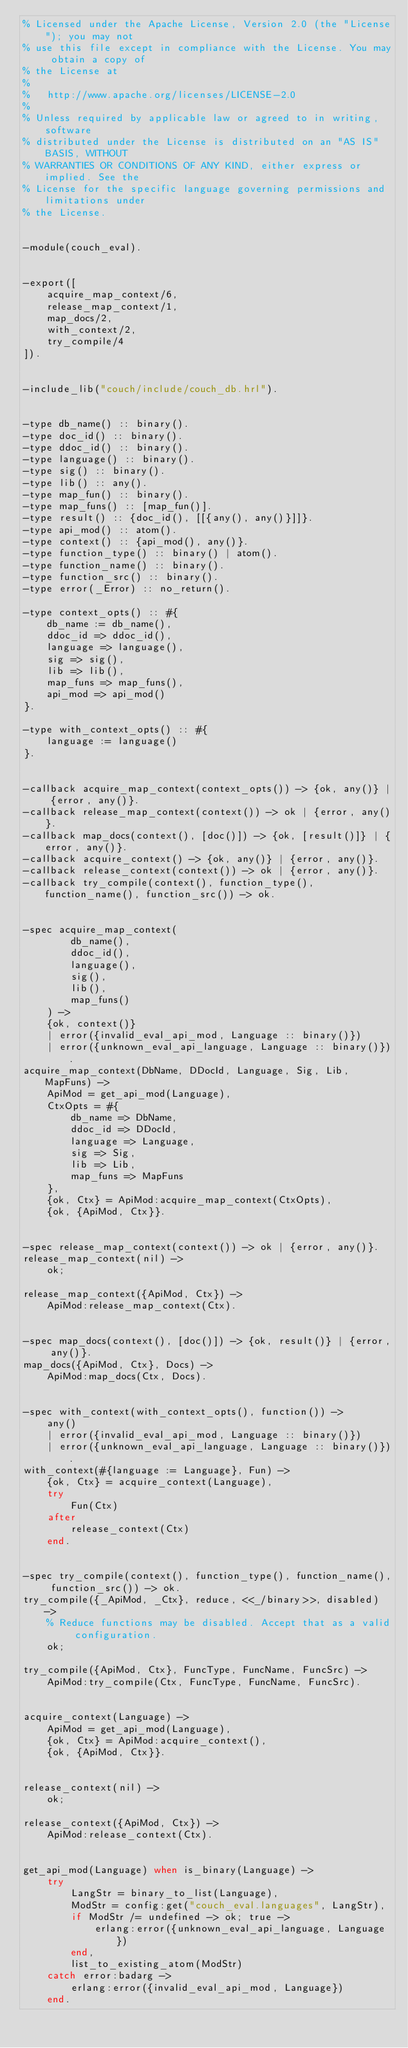<code> <loc_0><loc_0><loc_500><loc_500><_Erlang_>% Licensed under the Apache License, Version 2.0 (the "License"); you may not
% use this file except in compliance with the License. You may obtain a copy of
% the License at
%
%   http://www.apache.org/licenses/LICENSE-2.0
%
% Unless required by applicable law or agreed to in writing, software
% distributed under the License is distributed on an "AS IS" BASIS, WITHOUT
% WARRANTIES OR CONDITIONS OF ANY KIND, either express or implied. See the
% License for the specific language governing permissions and limitations under
% the License.


-module(couch_eval).


-export([
    acquire_map_context/6,
    release_map_context/1,
    map_docs/2,
    with_context/2,
    try_compile/4
]).


-include_lib("couch/include/couch_db.hrl").


-type db_name() :: binary().
-type doc_id() :: binary().
-type ddoc_id() :: binary().
-type language() :: binary().
-type sig() :: binary().
-type lib() :: any().
-type map_fun() :: binary().
-type map_funs() :: [map_fun()].
-type result() :: {doc_id(), [[{any(), any()}]]}.
-type api_mod() :: atom().
-type context() :: {api_mod(), any()}.
-type function_type() :: binary() | atom().
-type function_name() :: binary().
-type function_src() :: binary().
-type error(_Error) :: no_return().

-type context_opts() :: #{
    db_name := db_name(),
    ddoc_id => ddoc_id(),
    language => language(),
    sig => sig(),
    lib => lib(),
    map_funs => map_funs(),
    api_mod => api_mod()
}.

-type with_context_opts() :: #{
    language := language()
}.


-callback acquire_map_context(context_opts()) -> {ok, any()} | {error, any()}.
-callback release_map_context(context()) -> ok | {error, any()}.
-callback map_docs(context(), [doc()]) -> {ok, [result()]} | {error, any()}.
-callback acquire_context() -> {ok, any()} | {error, any()}.
-callback release_context(context()) -> ok | {error, any()}.
-callback try_compile(context(), function_type(), function_name(), function_src()) -> ok.


-spec acquire_map_context(
        db_name(),
        ddoc_id(),
        language(),
        sig(),
        lib(),
        map_funs()
    ) ->
    {ok, context()}
    | error({invalid_eval_api_mod, Language :: binary()})
    | error({unknown_eval_api_language, Language :: binary()}).
acquire_map_context(DbName, DDocId, Language, Sig, Lib, MapFuns) ->
    ApiMod = get_api_mod(Language),
    CtxOpts = #{
        db_name => DbName,
        ddoc_id => DDocId,
        language => Language,
        sig => Sig,
        lib => Lib,
        map_funs => MapFuns
    },
    {ok, Ctx} = ApiMod:acquire_map_context(CtxOpts),
    {ok, {ApiMod, Ctx}}.


-spec release_map_context(context()) -> ok | {error, any()}.
release_map_context(nil) ->
    ok;

release_map_context({ApiMod, Ctx}) ->
    ApiMod:release_map_context(Ctx).


-spec map_docs(context(), [doc()]) -> {ok, result()} | {error, any()}.
map_docs({ApiMod, Ctx}, Docs) ->
    ApiMod:map_docs(Ctx, Docs).


-spec with_context(with_context_opts(), function()) -> 
    any() 
    | error({invalid_eval_api_mod, Language :: binary()})
    | error({unknown_eval_api_language, Language :: binary()}).
with_context(#{language := Language}, Fun) ->
    {ok, Ctx} = acquire_context(Language),
    try 
        Fun(Ctx)
    after
        release_context(Ctx)
    end.


-spec try_compile(context(), function_type(), function_name(), function_src()) -> ok.
try_compile({_ApiMod, _Ctx}, reduce, <<_/binary>>, disabled) ->
    % Reduce functions may be disabled. Accept that as a valid configuration.
    ok;

try_compile({ApiMod, Ctx}, FuncType, FuncName, FuncSrc) -> 
    ApiMod:try_compile(Ctx, FuncType, FuncName, FuncSrc).


acquire_context(Language) ->
    ApiMod = get_api_mod(Language),
    {ok, Ctx} = ApiMod:acquire_context(),
    {ok, {ApiMod, Ctx}}.


release_context(nil) ->
    ok;

release_context({ApiMod, Ctx}) ->
    ApiMod:release_context(Ctx).


get_api_mod(Language) when is_binary(Language) ->
    try
        LangStr = binary_to_list(Language),
        ModStr = config:get("couch_eval.languages", LangStr),
        if ModStr /= undefined -> ok; true ->
            erlang:error({unknown_eval_api_language, Language})
        end,
        list_to_existing_atom(ModStr)
    catch error:badarg ->
        erlang:error({invalid_eval_api_mod, Language})
    end.
</code> 